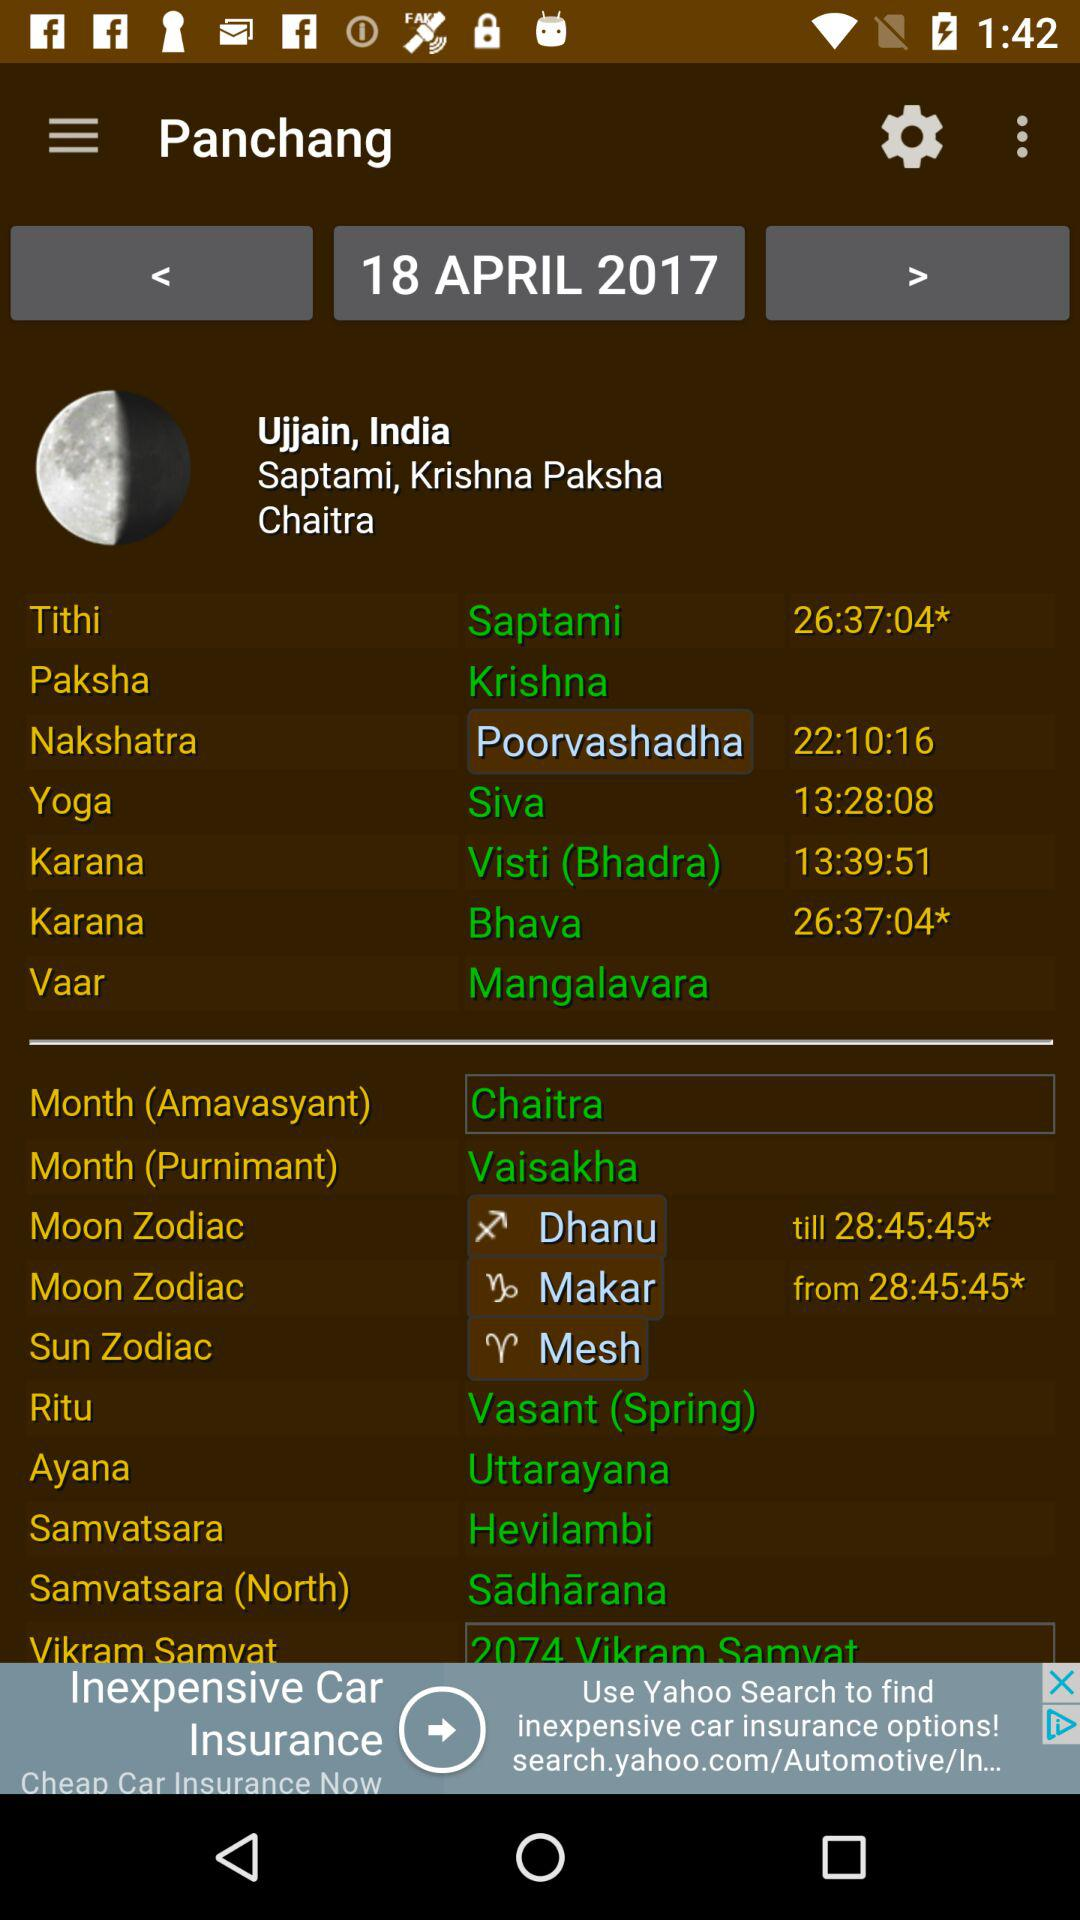What is the paksha? The paksha is "Krishna". 